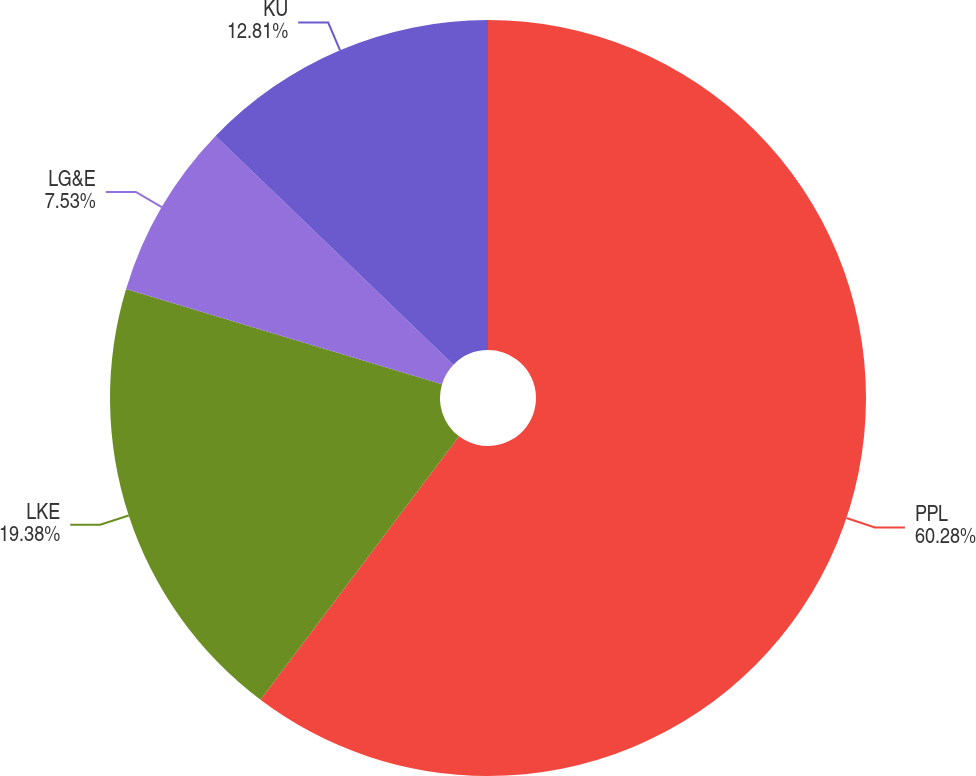Convert chart. <chart><loc_0><loc_0><loc_500><loc_500><pie_chart><fcel>PPL<fcel>LKE<fcel>LG&E<fcel>KU<nl><fcel>60.28%<fcel>19.38%<fcel>7.53%<fcel>12.81%<nl></chart> 